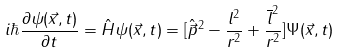Convert formula to latex. <formula><loc_0><loc_0><loc_500><loc_500>i \hbar { \frac { \partial \psi ( \vec { x } , t ) } { \partial t } } = \hat { H } \psi ( \vec { x } , t ) = [ \hat { \vec { p } } ^ { 2 } - \frac { l ^ { 2 } } { r ^ { 2 } } + \frac { \overline { l } ^ { 2 } } { r ^ { 2 } } ] \Psi ( \vec { x } , t )</formula> 